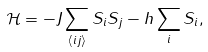<formula> <loc_0><loc_0><loc_500><loc_500>\mathcal { H } = - J \sum _ { \langle i j \rangle } S _ { i } S _ { j } - h \sum _ { i } S _ { i } ,</formula> 